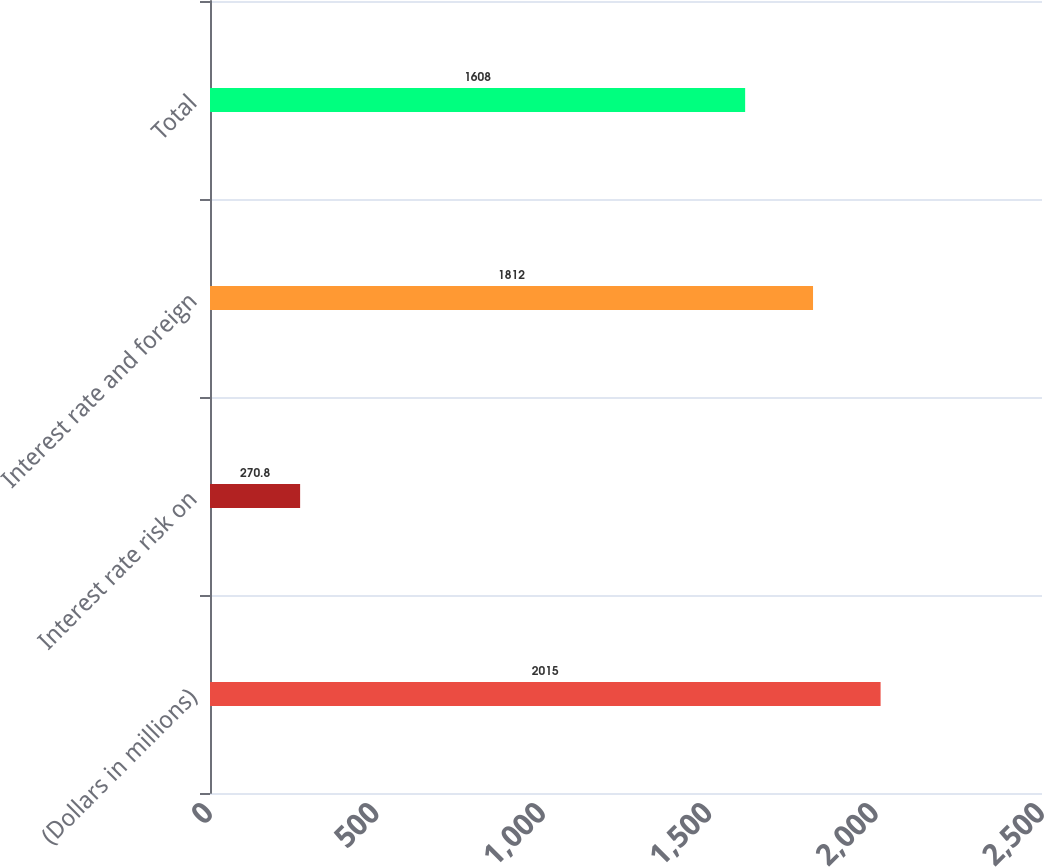<chart> <loc_0><loc_0><loc_500><loc_500><bar_chart><fcel>(Dollars in millions)<fcel>Interest rate risk on<fcel>Interest rate and foreign<fcel>Total<nl><fcel>2015<fcel>270.8<fcel>1812<fcel>1608<nl></chart> 